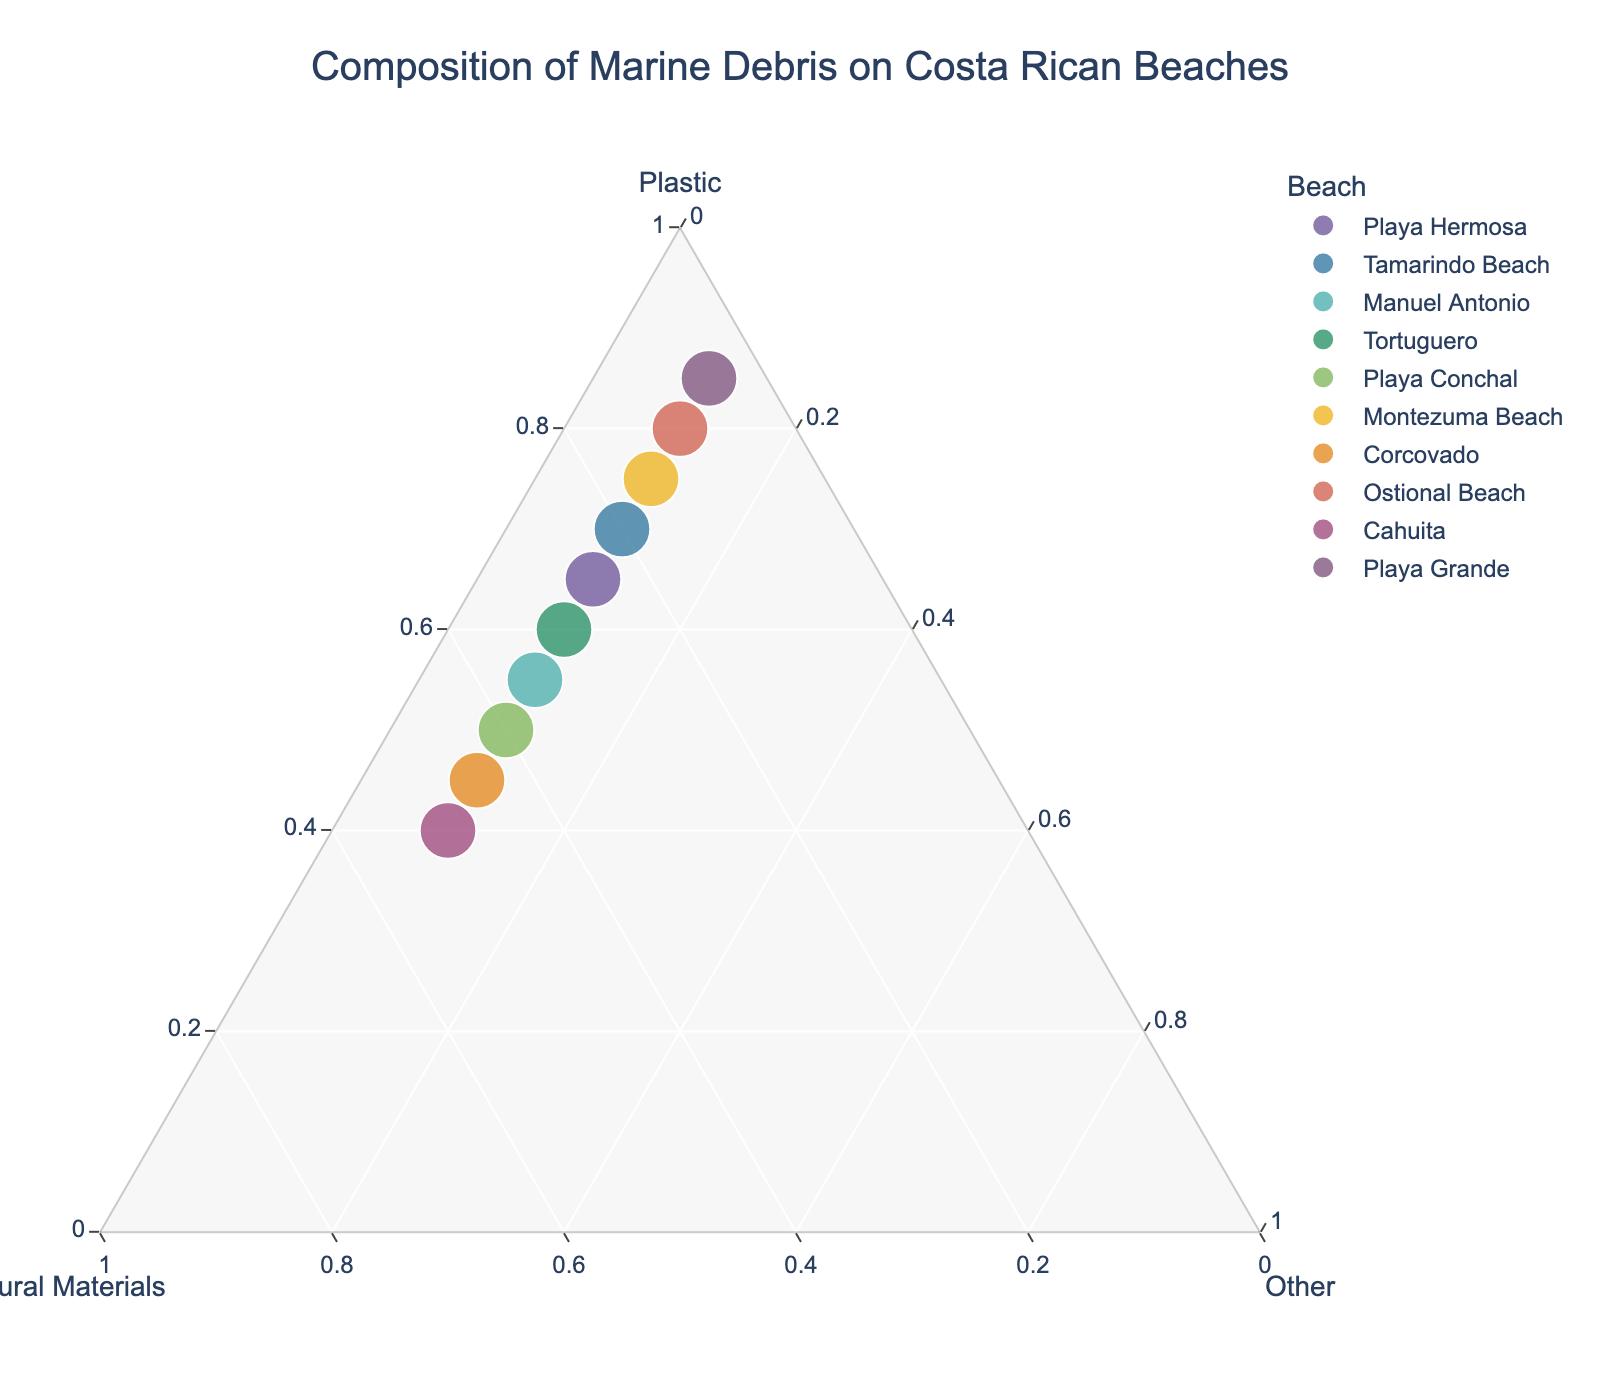How many beaches are represented in the plot? By looking at the number of distinct points or colors representing different beaches. There are 10 beaches plotted.
Answer: 10 Which beach has the highest proportion of plastic debris? Identify the point farthest from the "Plastic" axis. Playa Grande appears farthest from the Plastic axis at 85%.
Answer: Playa Grande Compare the amount of plastic between Playa Conchal and Tortuguero. Which beach has more plastic debris proportion? Locate the two data points and compare their positions along the Plastic axis. Playa Conchal has 50%, while Tortuguero has 60%.
Answer: Tortuguero What is the composition ratio of marine debris on Playa Hermosa? Playa Hermosa's coordinates on the ternary plot directly indicate the ratios. The ratios are 65% Plastic, 25% Natural Materials, and 10% Other.
Answer: 65% Plastic, 25% Natural Materials, 10% Other Is there any beach with equal proportions of Natural Materials and Plastic debris? Identify points with equal distances from the Natural Materials and Plastic axes. Corcovado has 45% each of Plastic and Natural Materials.
Answer: Corcovado Which beach has the lowest proportion of Natural Materials and what is the proportion? Look for the point closest to the Plastic axis. Playa Grande, with 5% Natural Materials, appears closest.
Answer: Playa Grande, 5% How does the composition of debris at Playa Conchal compare to Cahuita? Compare the coordinates for each beach across the axes. Playa Conchal: 50% Plastic, 40% Natural Materials. Cahuita: 40% Plastic, 50% Natural Materials. So, Playa Conchal has more plastic and less natural materials compared to Cahuita.
Answer: Playa Conchal has more plastic and less natural materials than Cahuita What is the overall trend in the proportion of 'Other' debris across all beaches? Check if any beach deviates significantly in the 'Other' axis. All beaches show a consistent 10% proportion of Other debris.
Answer: 10% consistent Which beaches have an equal proportion of 'Other' debris? Scan the 'Other' axis value across all beaches. All beaches have an equal proportion of 10%.
Answer: All beaches Identify the beach with the second-highest natural material debris proportion. Isolate the natural material debris proportions and find the highest and the second-highest values after Corcovado's 45%. Manuel Antonio with 35% is second-highest. The step-by-step identifying order is Corcovado (45%), then Manuel Antonio (35%).
Answer: Manuel Antonio 